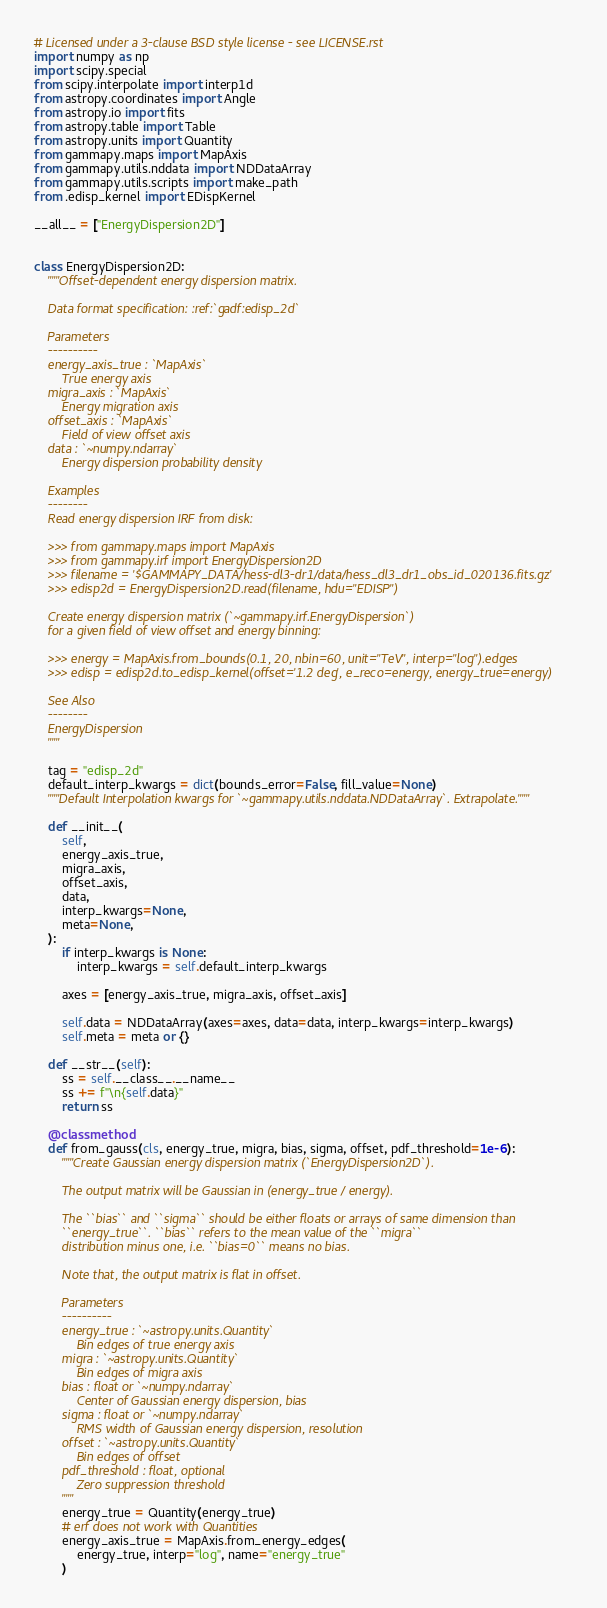Convert code to text. <code><loc_0><loc_0><loc_500><loc_500><_Python_># Licensed under a 3-clause BSD style license - see LICENSE.rst
import numpy as np
import scipy.special
from scipy.interpolate import interp1d
from astropy.coordinates import Angle
from astropy.io import fits
from astropy.table import Table
from astropy.units import Quantity
from gammapy.maps import MapAxis
from gammapy.utils.nddata import NDDataArray
from gammapy.utils.scripts import make_path
from .edisp_kernel import EDispKernel

__all__ = ["EnergyDispersion2D"]


class EnergyDispersion2D:
    """Offset-dependent energy dispersion matrix.

    Data format specification: :ref:`gadf:edisp_2d`

    Parameters
    ----------
    energy_axis_true : `MapAxis`
        True energy axis
    migra_axis : `MapAxis`
        Energy migration axis
    offset_axis : `MapAxis`
        Field of view offset axis
    data : `~numpy.ndarray`
        Energy dispersion probability density

    Examples
    --------
    Read energy dispersion IRF from disk:

    >>> from gammapy.maps import MapAxis
    >>> from gammapy.irf import EnergyDispersion2D
    >>> filename = '$GAMMAPY_DATA/hess-dl3-dr1/data/hess_dl3_dr1_obs_id_020136.fits.gz'
    >>> edisp2d = EnergyDispersion2D.read(filename, hdu="EDISP")

    Create energy dispersion matrix (`~gammapy.irf.EnergyDispersion`)
    for a given field of view offset and energy binning:

    >>> energy = MapAxis.from_bounds(0.1, 20, nbin=60, unit="TeV", interp="log").edges
    >>> edisp = edisp2d.to_edisp_kernel(offset='1.2 deg', e_reco=energy, energy_true=energy)

    See Also
    --------
    EnergyDispersion
    """

    tag = "edisp_2d"
    default_interp_kwargs = dict(bounds_error=False, fill_value=None)
    """Default Interpolation kwargs for `~gammapy.utils.nddata.NDDataArray`. Extrapolate."""

    def __init__(
        self,
        energy_axis_true,
        migra_axis,
        offset_axis,
        data,
        interp_kwargs=None,
        meta=None,
    ):
        if interp_kwargs is None:
            interp_kwargs = self.default_interp_kwargs

        axes = [energy_axis_true, migra_axis, offset_axis]

        self.data = NDDataArray(axes=axes, data=data, interp_kwargs=interp_kwargs)
        self.meta = meta or {}

    def __str__(self):
        ss = self.__class__.__name__
        ss += f"\n{self.data}"
        return ss

    @classmethod
    def from_gauss(cls, energy_true, migra, bias, sigma, offset, pdf_threshold=1e-6):
        """Create Gaussian energy dispersion matrix (`EnergyDispersion2D`).

        The output matrix will be Gaussian in (energy_true / energy).

        The ``bias`` and ``sigma`` should be either floats or arrays of same dimension than
        ``energy_true``. ``bias`` refers to the mean value of the ``migra``
        distribution minus one, i.e. ``bias=0`` means no bias.

        Note that, the output matrix is flat in offset.

        Parameters
        ----------
        energy_true : `~astropy.units.Quantity`
            Bin edges of true energy axis
        migra : `~astropy.units.Quantity`
            Bin edges of migra axis
        bias : float or `~numpy.ndarray`
            Center of Gaussian energy dispersion, bias
        sigma : float or `~numpy.ndarray`
            RMS width of Gaussian energy dispersion, resolution
        offset : `~astropy.units.Quantity`
            Bin edges of offset
        pdf_threshold : float, optional
            Zero suppression threshold
        """
        energy_true = Quantity(energy_true)
        # erf does not work with Quantities
        energy_axis_true = MapAxis.from_energy_edges(
            energy_true, interp="log", name="energy_true"
        )
</code> 